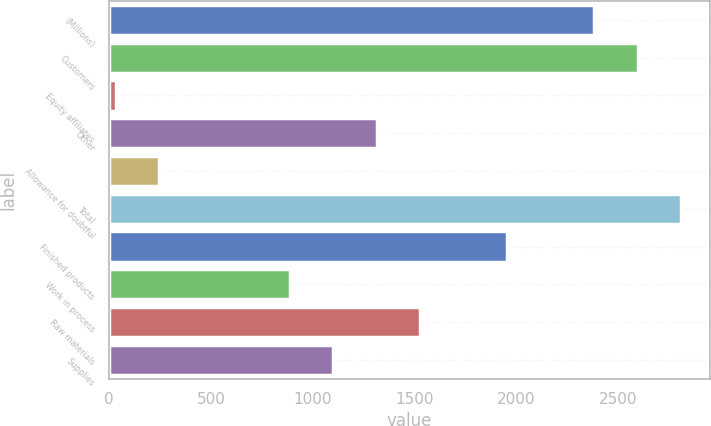Convert chart. <chart><loc_0><loc_0><loc_500><loc_500><bar_chart><fcel>(Millions)<fcel>Customers<fcel>Equity affiliates<fcel>Other<fcel>Allowance for doubtful<fcel>Total<fcel>Finished products<fcel>Work in process<fcel>Raw materials<fcel>Supplies<nl><fcel>2381.7<fcel>2595.4<fcel>31<fcel>1313.2<fcel>244.7<fcel>2809.1<fcel>1954.3<fcel>885.8<fcel>1526.9<fcel>1099.5<nl></chart> 